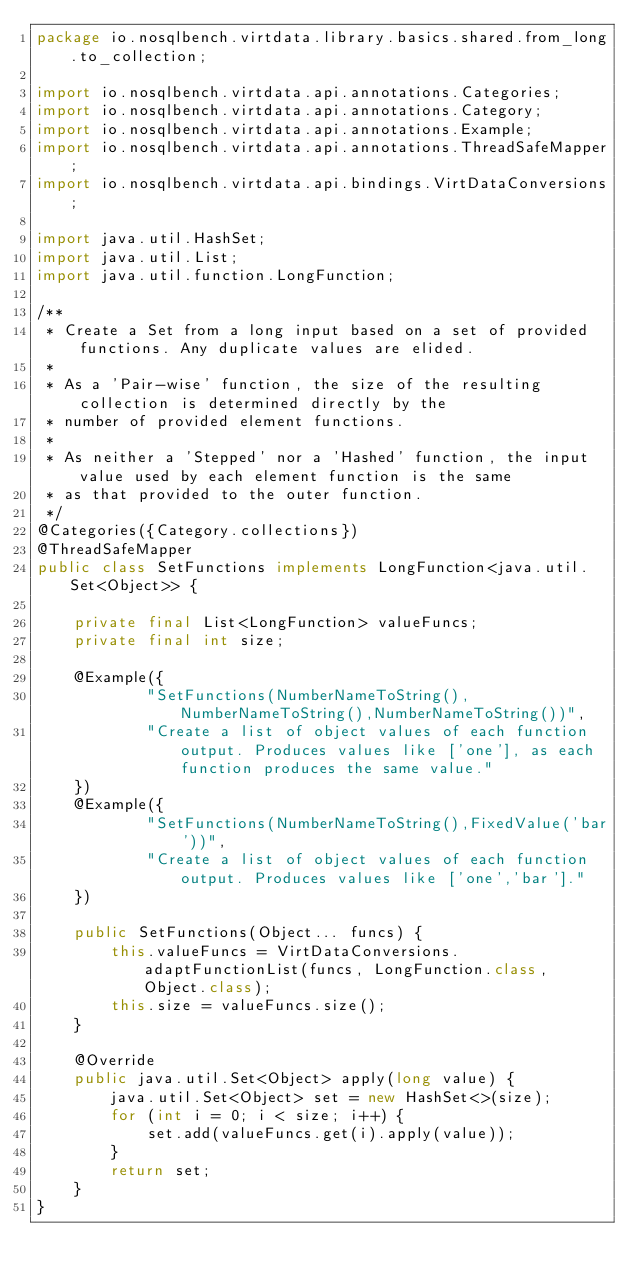<code> <loc_0><loc_0><loc_500><loc_500><_Java_>package io.nosqlbench.virtdata.library.basics.shared.from_long.to_collection;

import io.nosqlbench.virtdata.api.annotations.Categories;
import io.nosqlbench.virtdata.api.annotations.Category;
import io.nosqlbench.virtdata.api.annotations.Example;
import io.nosqlbench.virtdata.api.annotations.ThreadSafeMapper;
import io.nosqlbench.virtdata.api.bindings.VirtDataConversions;

import java.util.HashSet;
import java.util.List;
import java.util.function.LongFunction;

/**
 * Create a Set from a long input based on a set of provided functions. Any duplicate values are elided.
 *
 * As a 'Pair-wise' function, the size of the resulting collection is determined directly by the
 * number of provided element functions.
 *
 * As neither a 'Stepped' nor a 'Hashed' function, the input value used by each element function is the same
 * as that provided to the outer function.
 */
@Categories({Category.collections})
@ThreadSafeMapper
public class SetFunctions implements LongFunction<java.util.Set<Object>> {

    private final List<LongFunction> valueFuncs;
    private final int size;

    @Example({
            "SetFunctions(NumberNameToString(),NumberNameToString(),NumberNameToString())",
            "Create a list of object values of each function output. Produces values like ['one'], as each function produces the same value."
    })
    @Example({
            "SetFunctions(NumberNameToString(),FixedValue('bar'))",
            "Create a list of object values of each function output. Produces values like ['one','bar']."
    })

    public SetFunctions(Object... funcs) {
        this.valueFuncs = VirtDataConversions.adaptFunctionList(funcs, LongFunction.class, Object.class);
        this.size = valueFuncs.size();
    }

    @Override
    public java.util.Set<Object> apply(long value) {
        java.util.Set<Object> set = new HashSet<>(size);
        for (int i = 0; i < size; i++) {
            set.add(valueFuncs.get(i).apply(value));
        }
        return set;
    }
}
</code> 